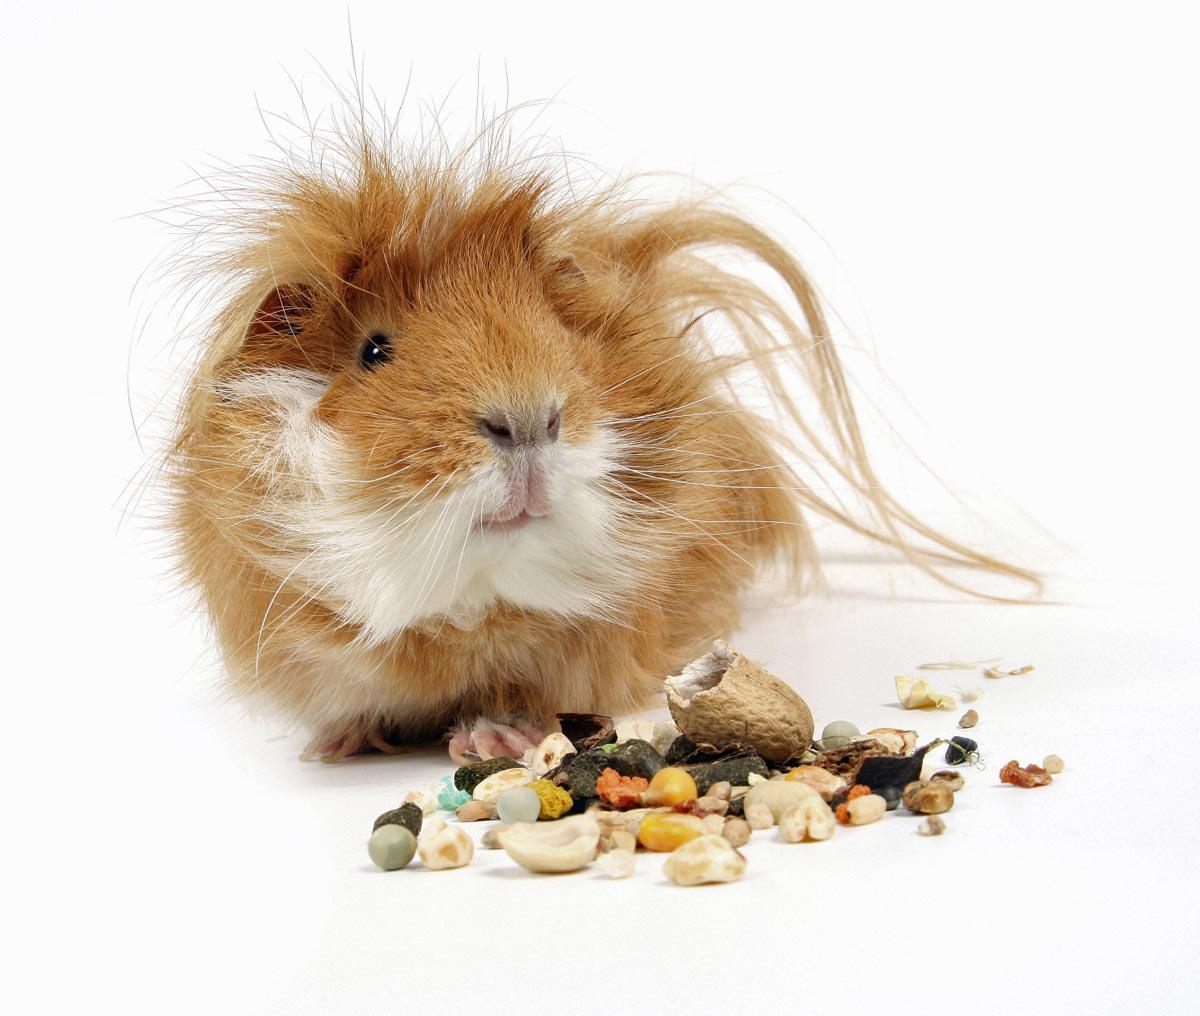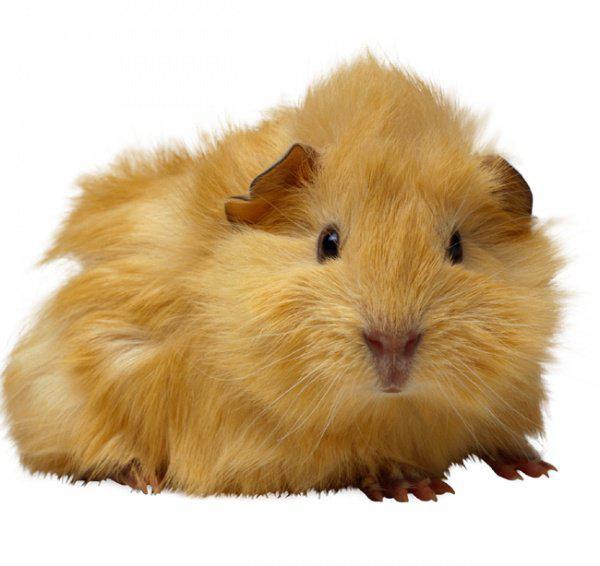The first image is the image on the left, the second image is the image on the right. Evaluate the accuracy of this statement regarding the images: "The image on the left contains food.". Is it true? Answer yes or no. Yes. 